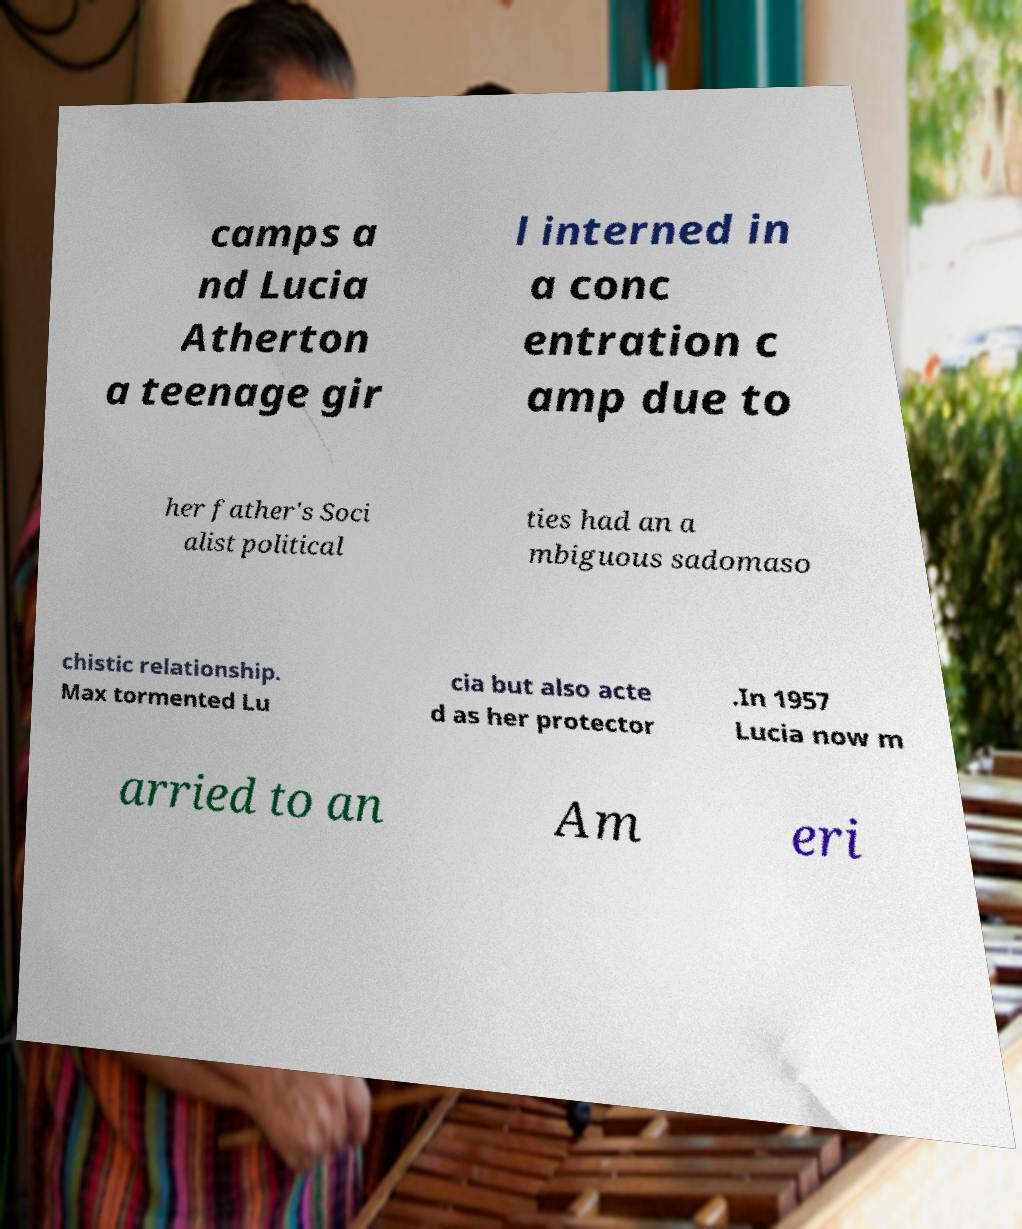Can you read and provide the text displayed in the image?This photo seems to have some interesting text. Can you extract and type it out for me? camps a nd Lucia Atherton a teenage gir l interned in a conc entration c amp due to her father's Soci alist political ties had an a mbiguous sadomaso chistic relationship. Max tormented Lu cia but also acte d as her protector .In 1957 Lucia now m arried to an Am eri 